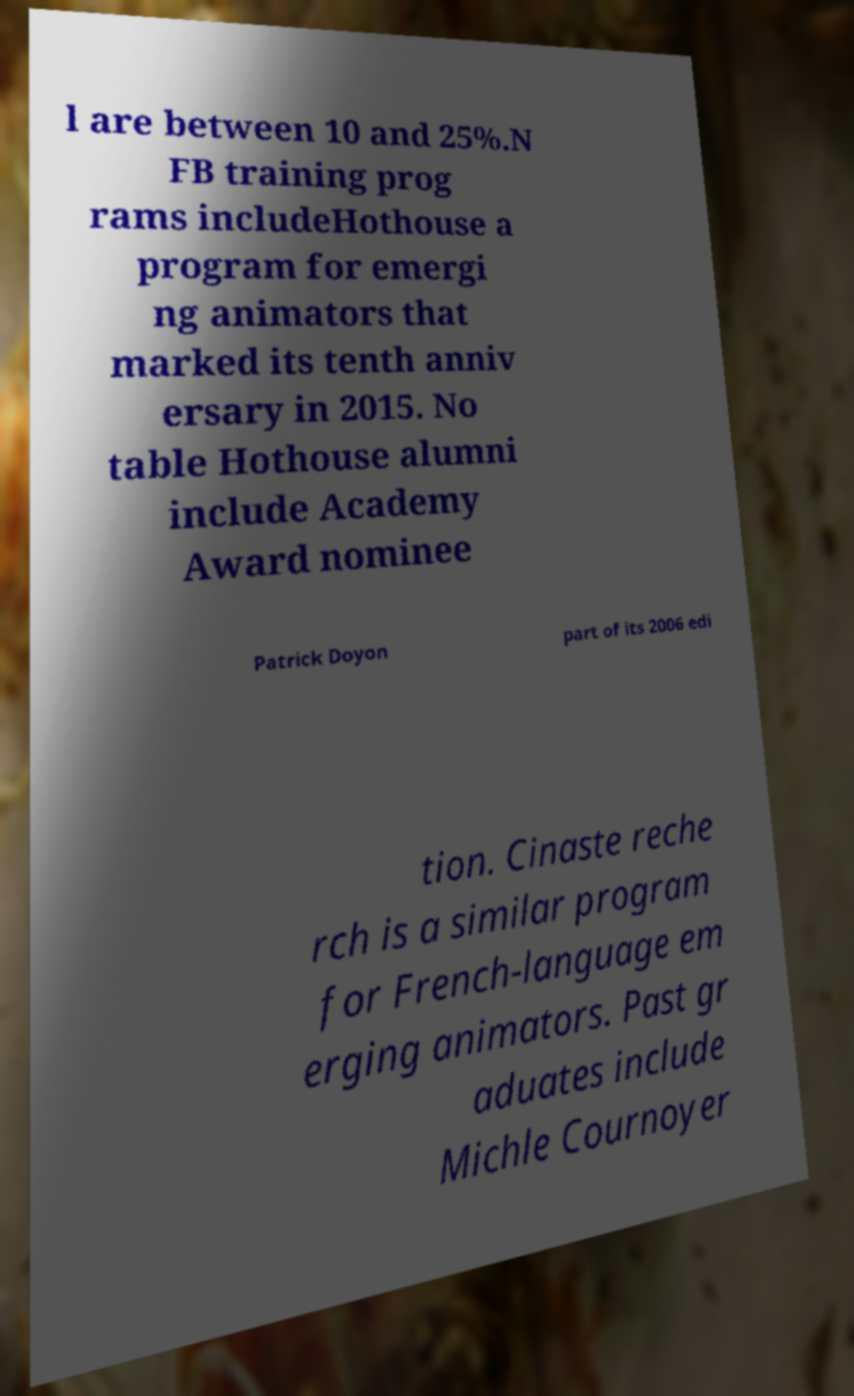Can you accurately transcribe the text from the provided image for me? l are between 10 and 25%.N FB training prog rams includeHothouse a program for emergi ng animators that marked its tenth anniv ersary in 2015. No table Hothouse alumni include Academy Award nominee Patrick Doyon part of its 2006 edi tion. Cinaste reche rch is a similar program for French-language em erging animators. Past gr aduates include Michle Cournoyer 